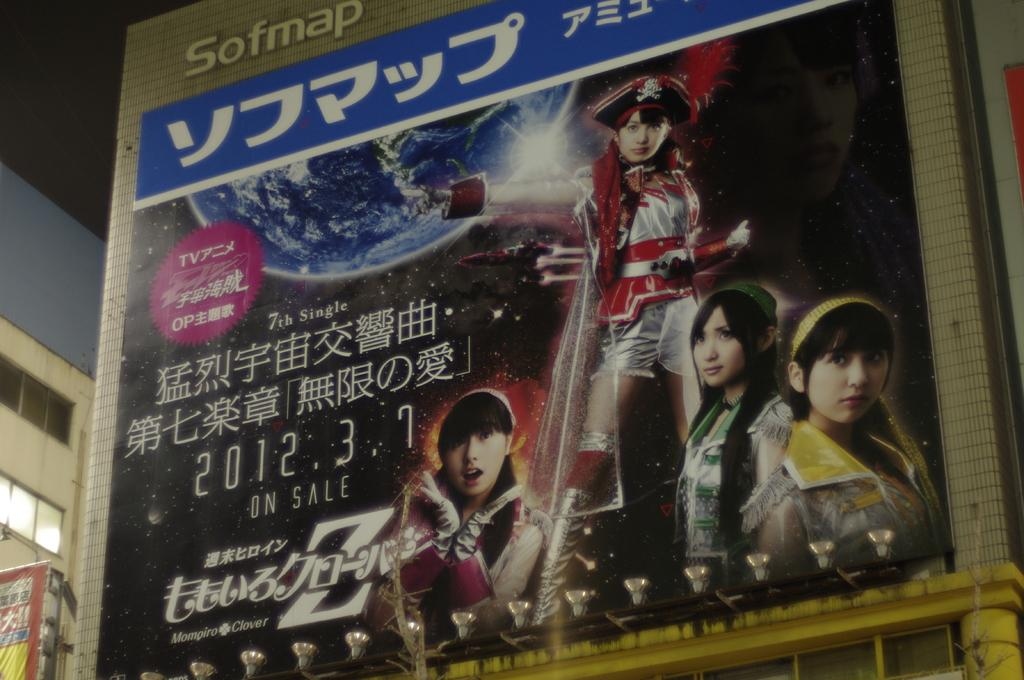What can be seen hanging in the image? There are banners in the image. What is visible behind the banners? There are buildings visible behind the banners. What type of paste is being used to hold the banners together in the image? There is no information about paste or any adhesive being used in the image; the banners are simply hanging. 